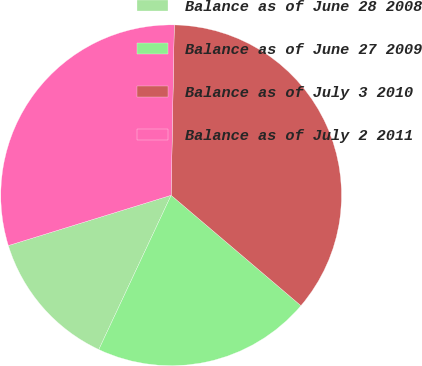Convert chart to OTSL. <chart><loc_0><loc_0><loc_500><loc_500><pie_chart><fcel>Balance as of June 28 2008<fcel>Balance as of June 27 2009<fcel>Balance as of July 3 2010<fcel>Balance as of July 2 2011<nl><fcel>13.25%<fcel>20.76%<fcel>35.92%<fcel>30.06%<nl></chart> 